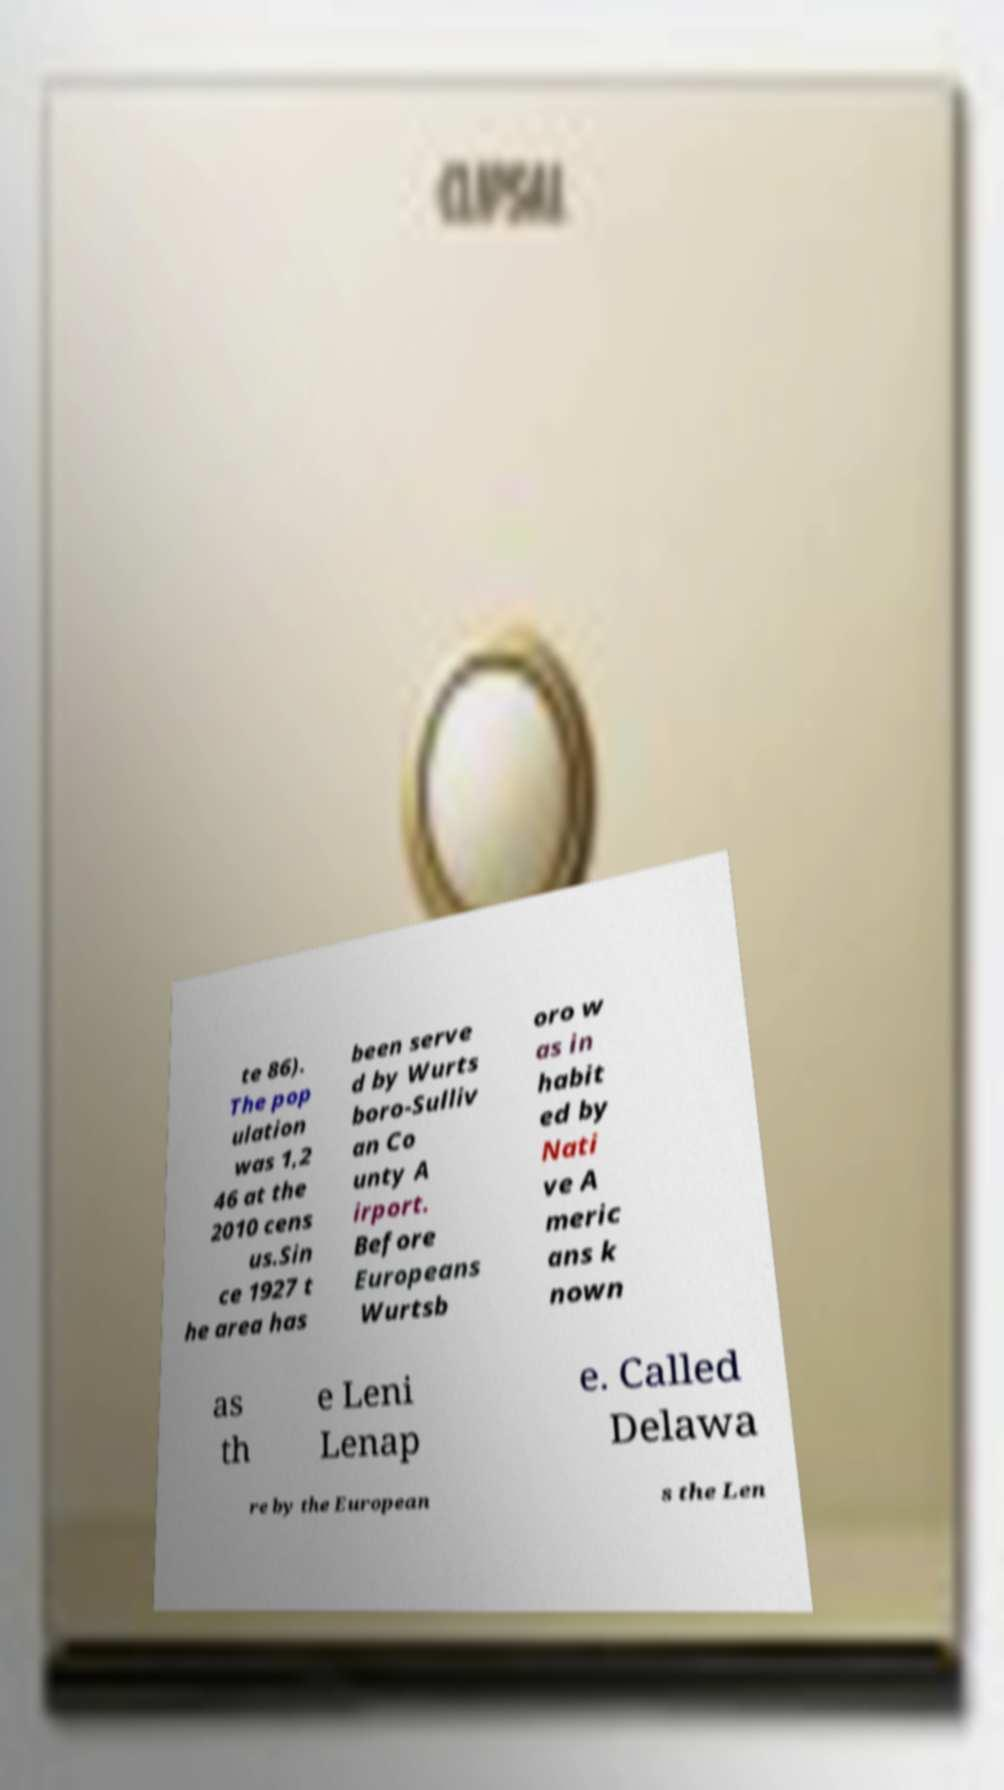I need the written content from this picture converted into text. Can you do that? te 86). The pop ulation was 1,2 46 at the 2010 cens us.Sin ce 1927 t he area has been serve d by Wurts boro-Sulliv an Co unty A irport. Before Europeans Wurtsb oro w as in habit ed by Nati ve A meric ans k nown as th e Leni Lenap e. Called Delawa re by the European s the Len 